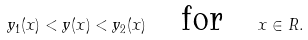<formula> <loc_0><loc_0><loc_500><loc_500>y _ { 1 } ( x ) < y ( x ) < y _ { 2 } ( x ) \quad \text {for} \quad x \in R .</formula> 